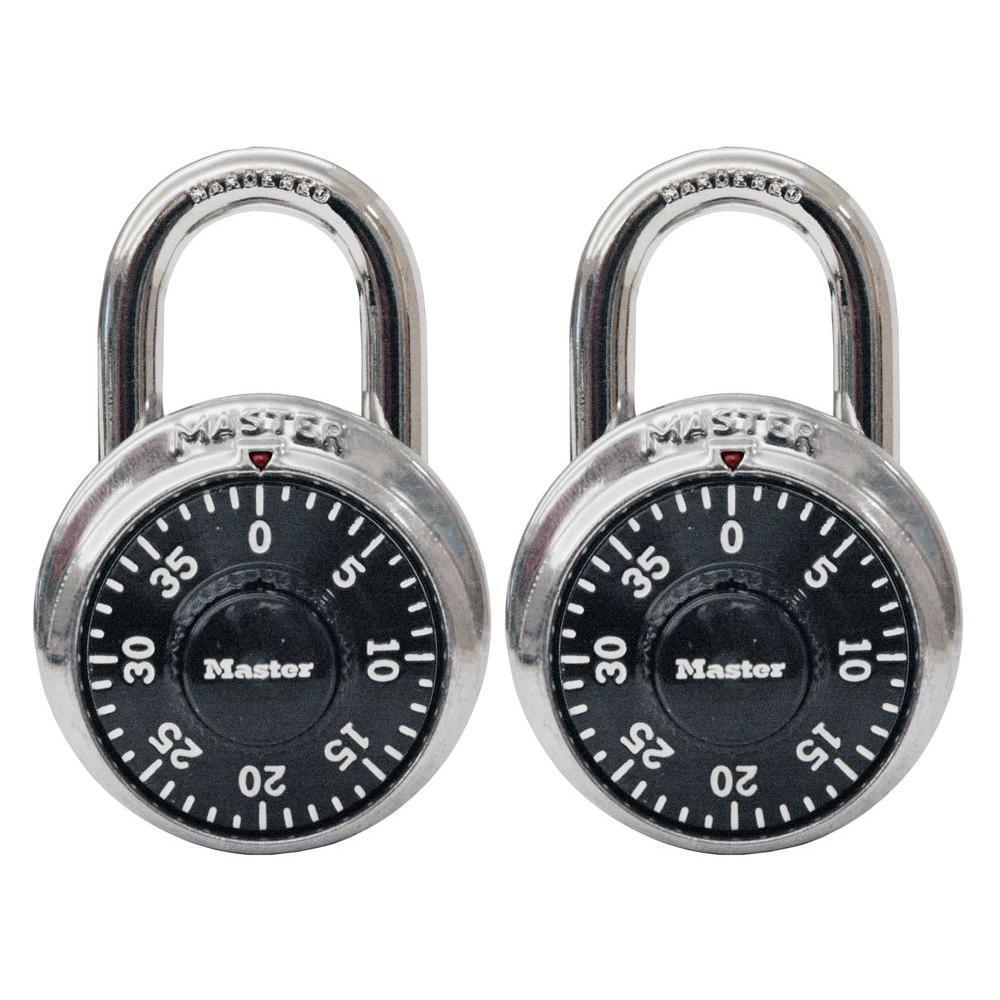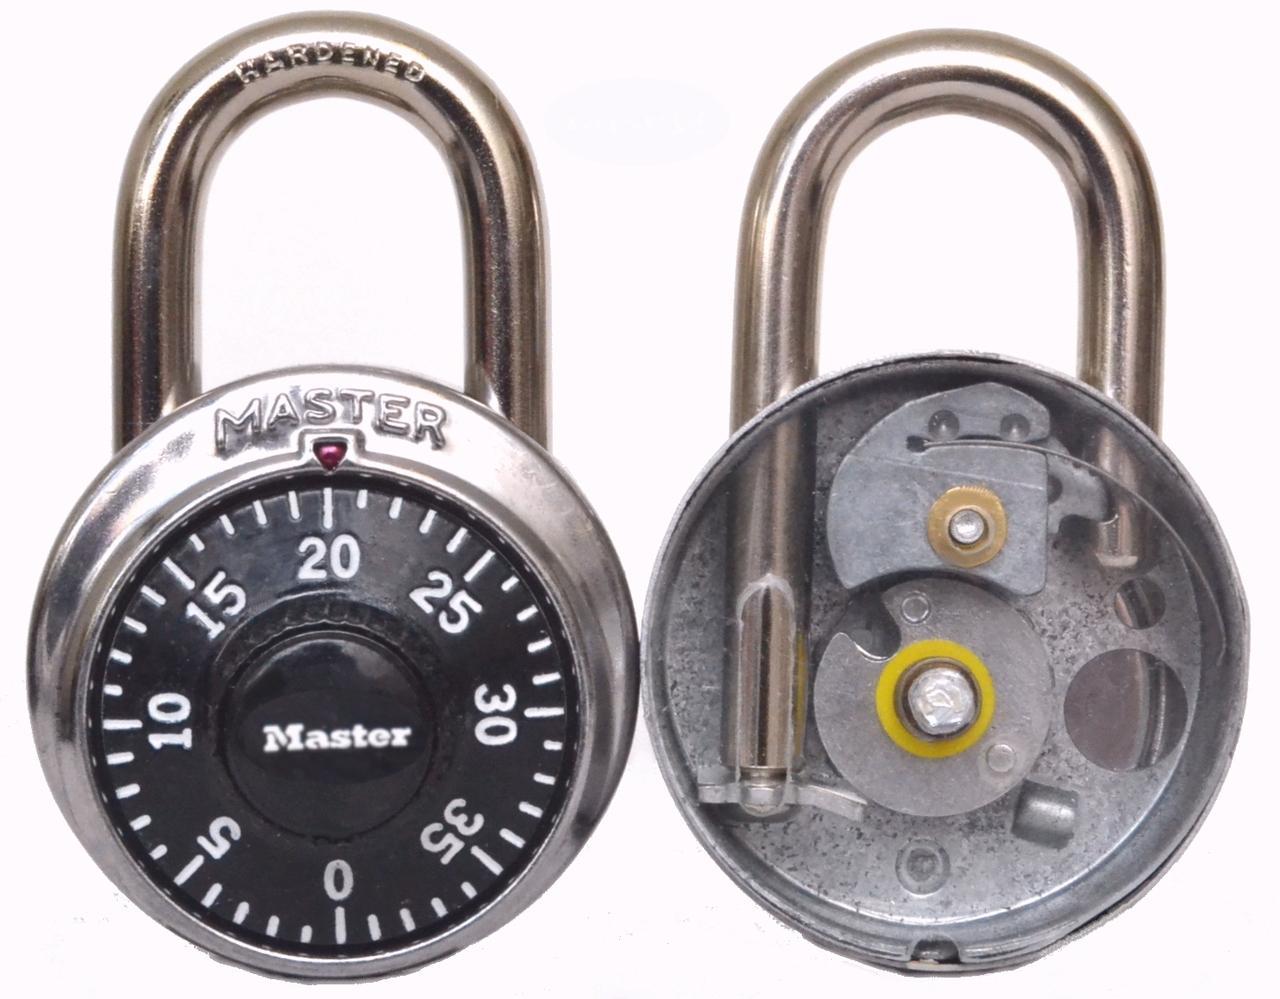The first image is the image on the left, the second image is the image on the right. Examine the images to the left and right. Is the description "An image includes a capsule-shaped lock with a combination wheel containing white letters and numbers on black." accurate? Answer yes or no. No. The first image is the image on the left, the second image is the image on the right. Examine the images to the left and right. Is the description "There are at most 3 padlocks in total." accurate? Answer yes or no. No. 